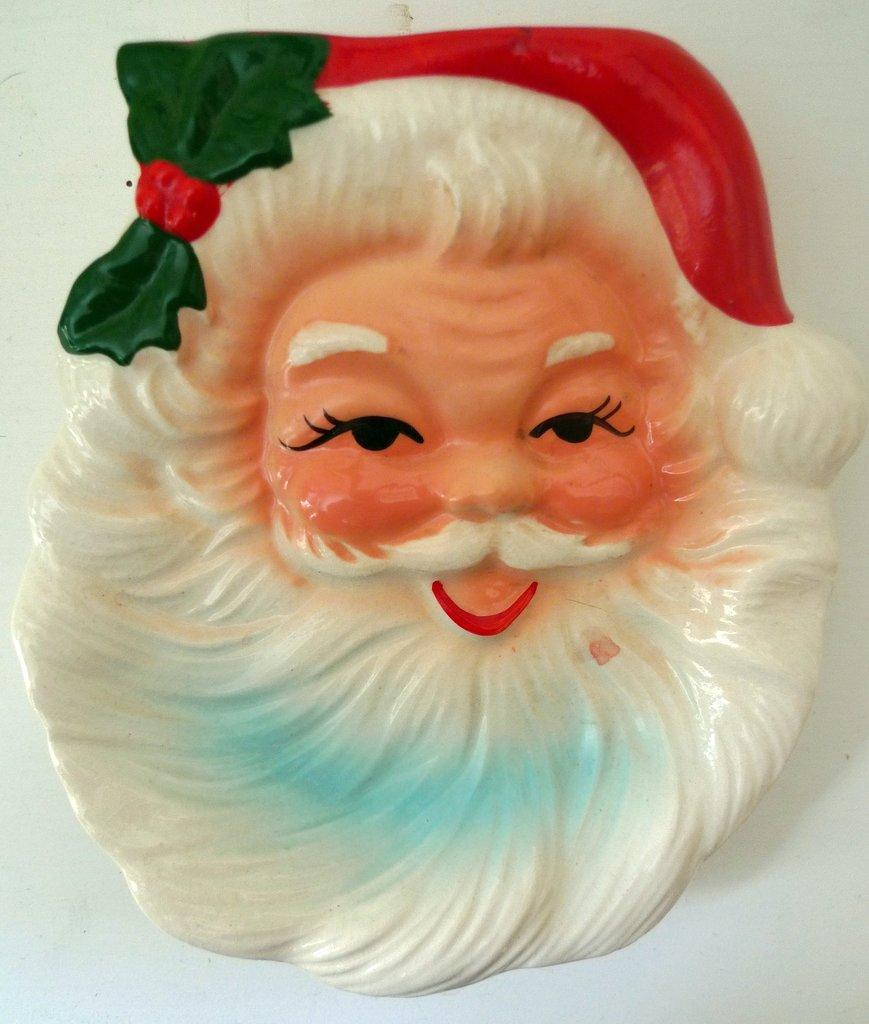What is the main subject of the image? The main subject of the image is a santa claus head. What is the background or surface on which the santa claus head is placed? The santa claus head is on a white surface. What type of society is depicted in the image? There is no society depicted in the image; it features a santa claus head on a white surface. What is the range of colors used in the image? The image primarily features two colors: the red and white of the santa claus head and the white surface it is placed on. However, there is no canvas present in the image. 